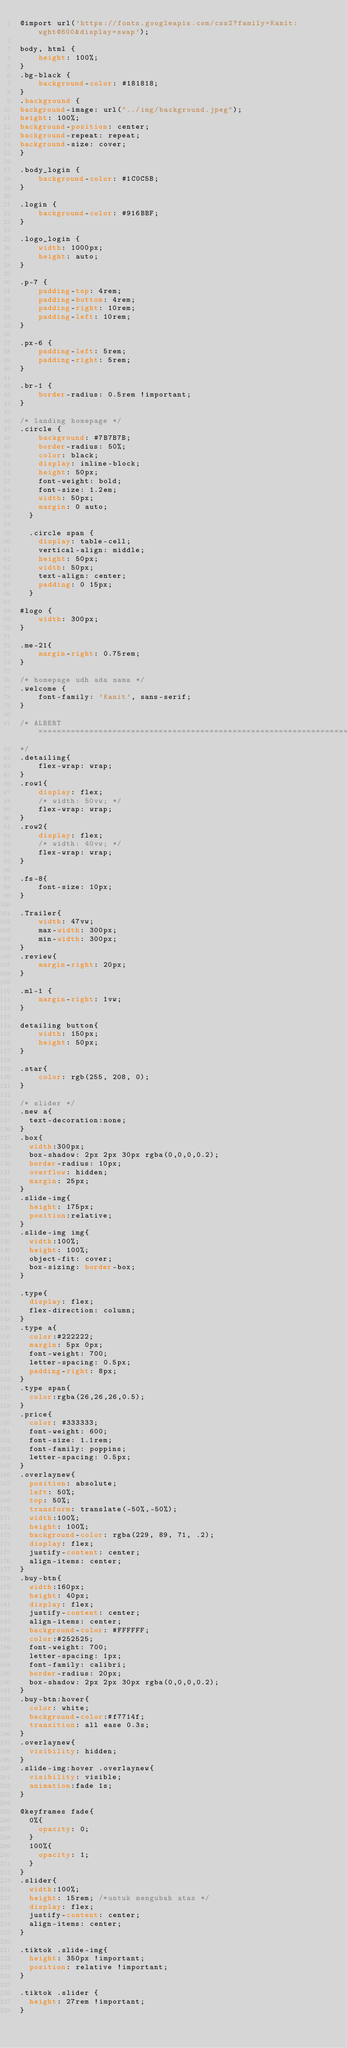<code> <loc_0><loc_0><loc_500><loc_500><_CSS_>@import url('https://fonts.googleapis.com/css2?family=Kanit:wght@600&display=swap');

body, html {
    height: 100%;
}
.bg-black {
    background-color: #181818;
} 
.background {
background-image: url("../img/background.jpeg");
height: 100%;
background-position: center;
background-repeat: repeat;
background-size: cover;
}

.body_login {
    background-color: #1C0C5B;
}

.login {
    background-color: #916BBF;
}

.logo_login {
    width: 1000px;
    height: auto;
}

.p-7 {
    padding-top: 4rem;
    padding-bottom: 4rem;
    padding-right: 10rem;
    padding-left: 10rem;
}

.px-6 {
    padding-left: 5rem;
    padding-right: 5rem;
}

.br-1 {
    border-radius: 0.5rem !important;
}

/* landing homepage */
.circle {
    background: #7B7B7B;
    border-radius: 50%;
    color: black;
    display: inline-block;
    height: 50px;
    font-weight: bold;
    font-size: 1.2em;
    width: 50px;
    margin: 0 auto;
  }
  
  .circle span {
    display: table-cell;
    vertical-align: middle;
    height: 50px;
    width: 50px;
    text-align: center;
    padding: 0 15px;
  }

#logo {
    width: 300px;
}

.me-21{
    margin-right: 0.75rem;
}

/* homepage udh ada nama */
.welcome {
    font-family: 'Kanit', sans-serif;
}

/* ALBERT ====================================================================
*/
.detailing{
    flex-wrap: wrap;
}
.row1{
    display: flex;
    /* width: 50vw; */
    flex-wrap: wrap;
}
.row2{
    display: flex;
    /* width: 40vw; */
    flex-wrap: wrap;
} 

.fs-8{
    font-size: 10px;
}

.Trailer{
    width: 47vw;
    max-width: 300px;
    min-width: 300px;
}
.review{
    margin-right: 20px;
}

.ml-1 {
    margin-right: 1vw;
}

detailing button{
    width: 150px;
    height: 50px;
}

.star{
    color: rgb(255, 208, 0);
}

/* slider */
.new a{
	text-decoration:none;
}
.box{
	width:300px;
	box-shadow: 2px 2px 30px rgba(0,0,0,0.2);
	border-radius: 10px;
	overflow: hidden;
	margin: 25px;
}
.slide-img{
	height: 175px;
	position:relative;
}
.slide-img img{
	width:100%;
	height: 100%;
	object-fit: cover;
	box-sizing: border-box;
}

.type{
	display: flex;
	flex-direction: column;
}
.type a{
	color:#222222;
	margin: 5px 0px;
	font-weight: 700;
	letter-spacing: 0.5px;
	padding-right: 8px;
}
.type span{
	color:rgba(26,26,26,0.5);
}
.price{
	color: #333333;
	font-weight: 600;
	font-size: 1.1rem;
	font-family: poppins;
	letter-spacing: 0.5px;
}
.overlaynew{
	position: absolute;
	left: 50%;
	top: 50%;
	transform: translate(-50%,-50%);
	width:100%;
	height: 100%;
	background-color: rgba(229, 89, 71, .2);
	display: flex;
	justify-content: center;
	align-items: center;
}
.buy-btn{
	width:160px;
	height: 40px;
	display: flex;
	justify-content: center;
	align-items: center;
	background-color: #FFFFFF;
	color:#252525;
	font-weight: 700;
	letter-spacing: 1px;
	font-family: calibri;
	border-radius: 20px;
	box-shadow: 2px 2px 30px rgba(0,0,0,0.2);
}
.buy-btn:hover{
	color: white;
	background-color:#f7714f;
	transition: all ease 0.3s;
}
.overlaynew{
	visibility: hidden;
}
.slide-img:hover .overlaynew{
	visibility: visible;
	animation:fade 1s;
}
 
@keyframes fade{
	0%{
		opacity: 0;
	}
	100%{
		opacity: 1;
	}
}
.slider{
	width:100%;
	height: 15rem; /*untuk mengubah atas */
	display: flex;
	justify-content: center;
	align-items: center;
}

.tiktok .slide-img{
	height: 350px !important;
	position: relative !important;
}

.tiktok .slider {
	height: 27rem !important;
}</code> 